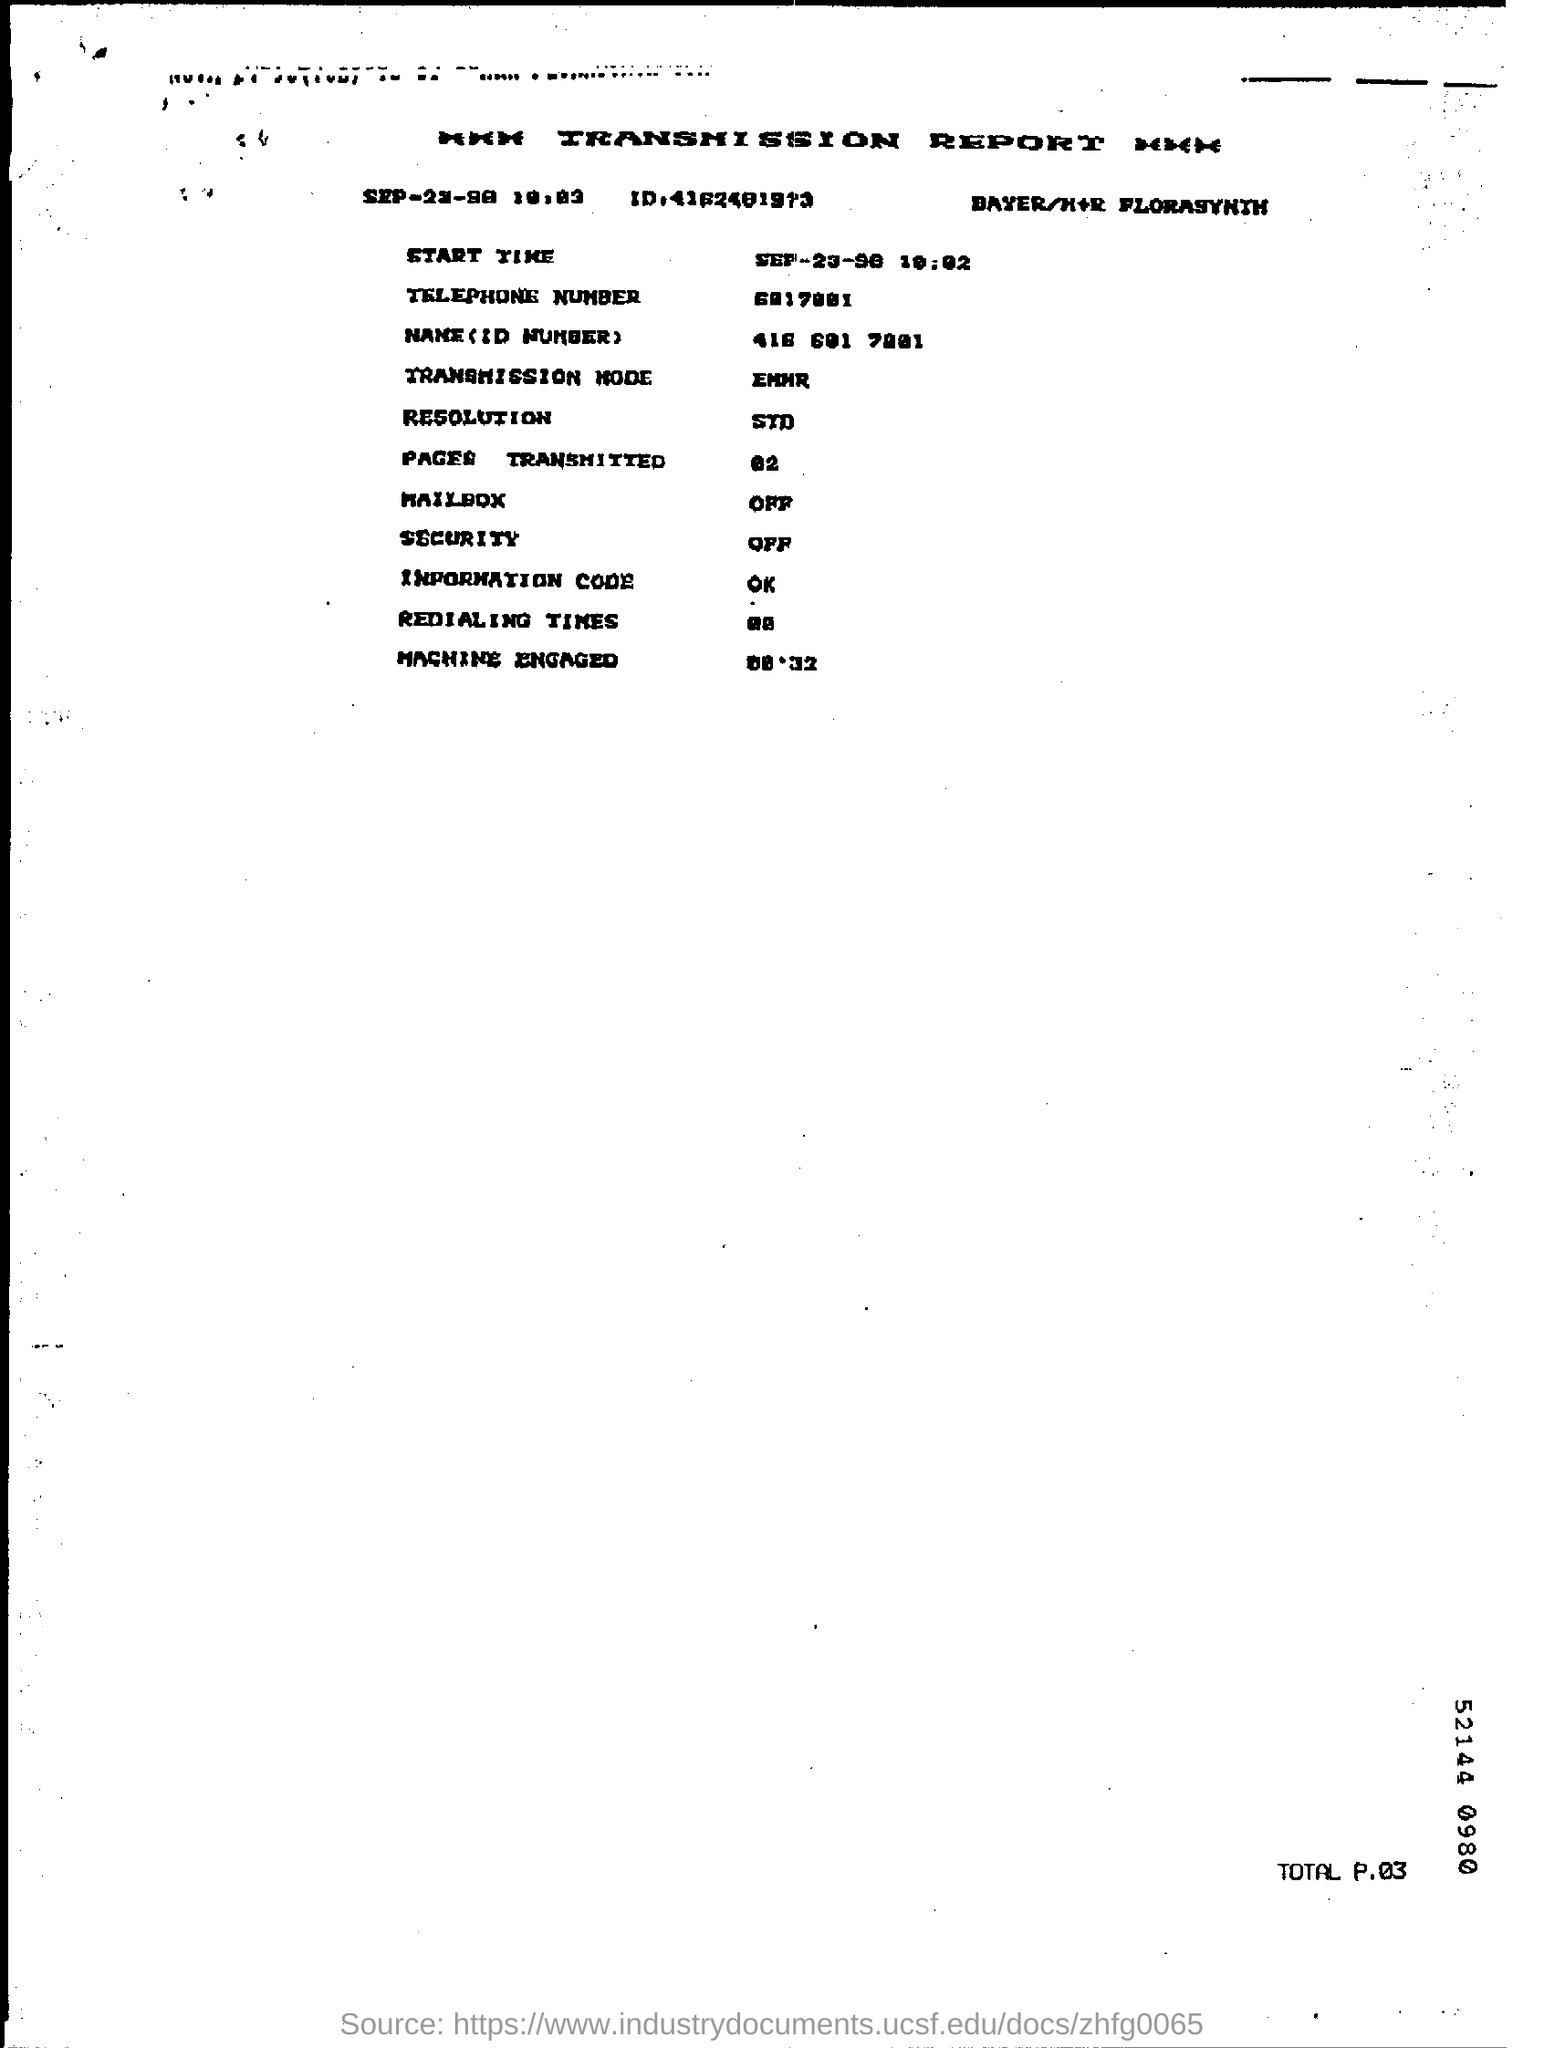Draw attention to some important aspects in this diagram. The resolution is STD. The Information Code is a concept or principle that is known as "ok.." in the context of understanding a person who is using the Information Code to communicate. The Mailbox is a feature that allows users to send and receive electronic messages through a computer network. The pages transmitted are 02. What is the Security for the release of the AIA document? Must it be notarized or can it be signed by an attorney or a CPA? 